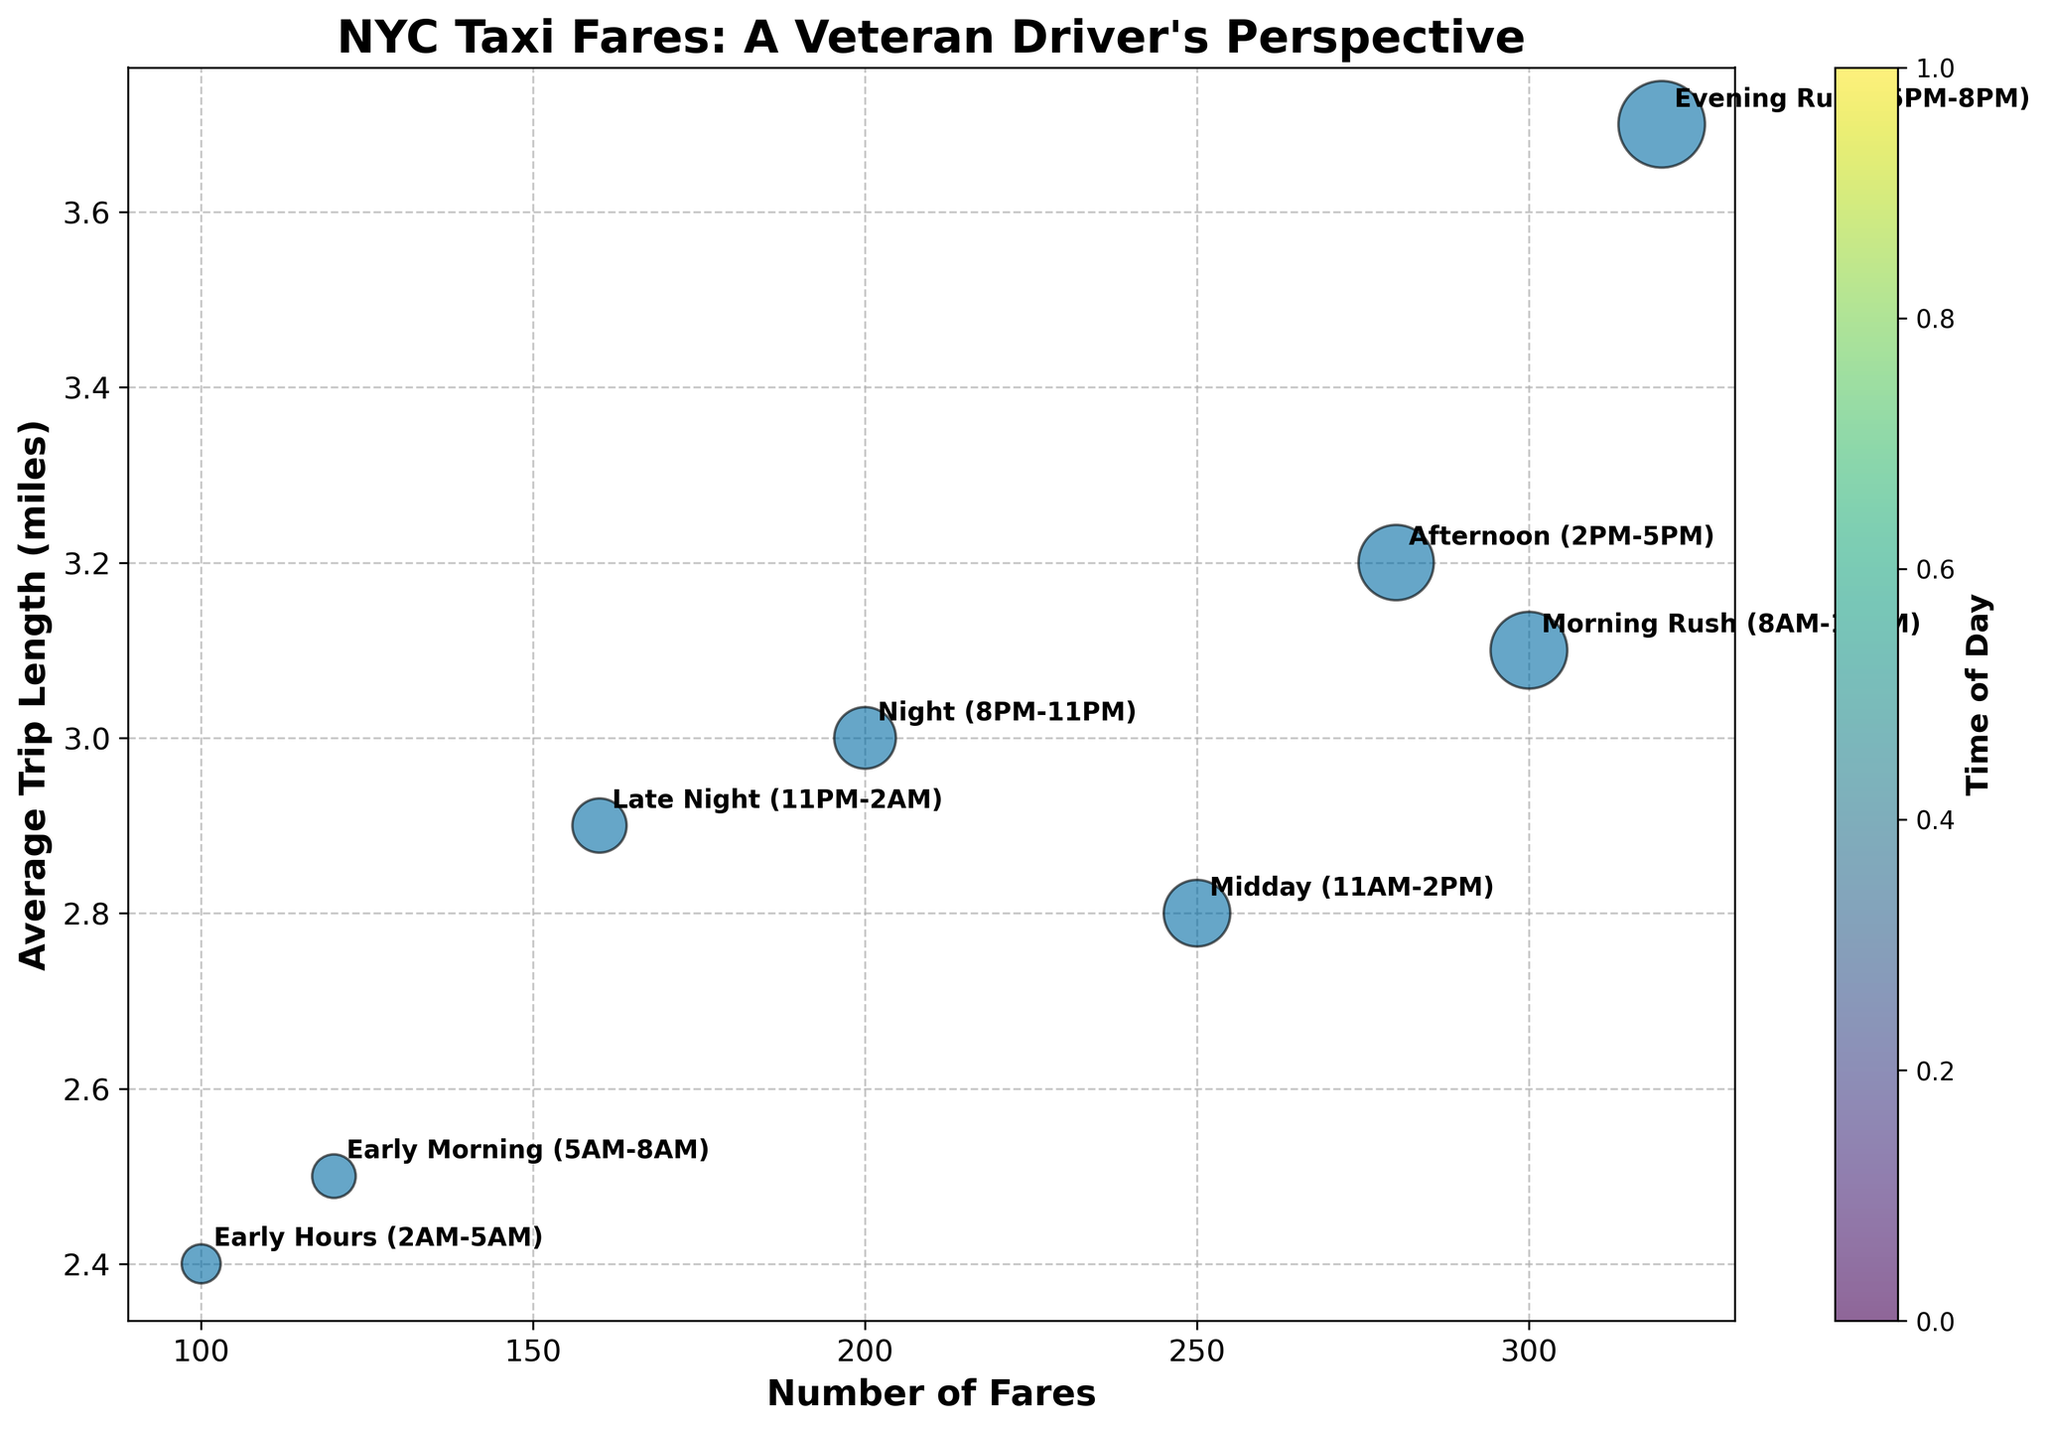How many times of day are represented in the chart? There are 8 times of day listed in the data. Each of these times of day is represented as a bubble on the chart.
Answer: 8 Which time of day has the highest number of fares? By looking at the x-axis, the time of day with the highest number of fares would be the one farthest to the right. This corresponds to the Evening Rush (5PM-8PM) with 320 fares.
Answer: Evening Rush (5PM-8PM) Which time of day has the shortest average trip length? By looking at the y-axis, the time of day with the lowest average trip length would be the one closest to the bottom. This corresponds to the Early Hours (2AM-5AM) with an average trip length of 2.4 miles.
Answer: Early Hours (2AM-5AM) Which time of day has the largest bubble? The bubble size is proportional to the product of the number of fares and the average trip length. Based on this, the time of day with the largest bubble is the Evening Rush (5PM-8PM) since it has the highest number of fares and a relatively high average trip length.
Answer: Evening Rush (5PM-8PM) What is the average trip length during the Morning Rush (8AM-11AM)? The Morning Rush (8AM-11AM) is represented by a bubble on the chart. The y-coordinate of this bubble gives the average trip length.
Answer: 3.1 miles How does the average trip length during Midday (11AM-2PM) compare to Night (8PM-11PM)? Compare the y-coordinates of the bubbles representing Midday (11AM-2PM) and Night (8PM-11PM). Midday's average trip length is 2.8 miles, whereas Night's is 3.0 miles.
Answer: Midday is shorter What is the total number of fares from Early Morning (5AM-8AM) to Midday (11AM-2PM)? Sum the number of fares from Early Morning (120) and Morning Rush (300) and Midday (250). 120 + 300 + 250 = 670.
Answer: 670 Which time of day has a higher average trip length: Morning Rush (8AM-11AM) or Late Night (11PM-2AM)? Compare the y-coordinates of the bubbles representing Morning Rush (8AM-11AM) and Late Night (11PM-2AM). Morning Rush has an average trip length of 3.1 miles, whereas Late Night's is 2.9 miles.
Answer: Morning Rush (8AM-11AM) If you were to rank the times of day by the number of fares, what would be the rank of Afternoon (2PM-5PM)? By ordering the times of day by their number of fares, we see: Evening Rush (320), Afternoon (280), Morning Rush (300), Midday (250), Night (200), Late Night (160), Early Morning (120), and Early Hours (100). Afternoon ranks third.
Answer: Third 